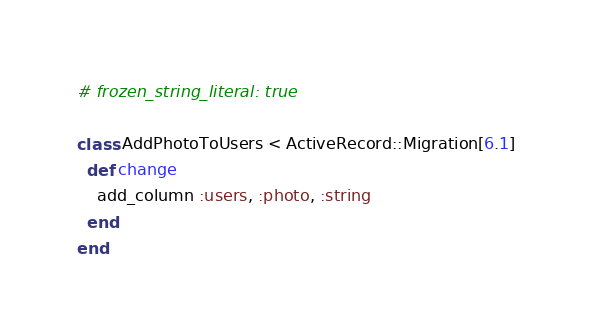<code> <loc_0><loc_0><loc_500><loc_500><_Ruby_># frozen_string_literal: true

class AddPhotoToUsers < ActiveRecord::Migration[6.1]
  def change
    add_column :users, :photo, :string
  end
end
</code> 